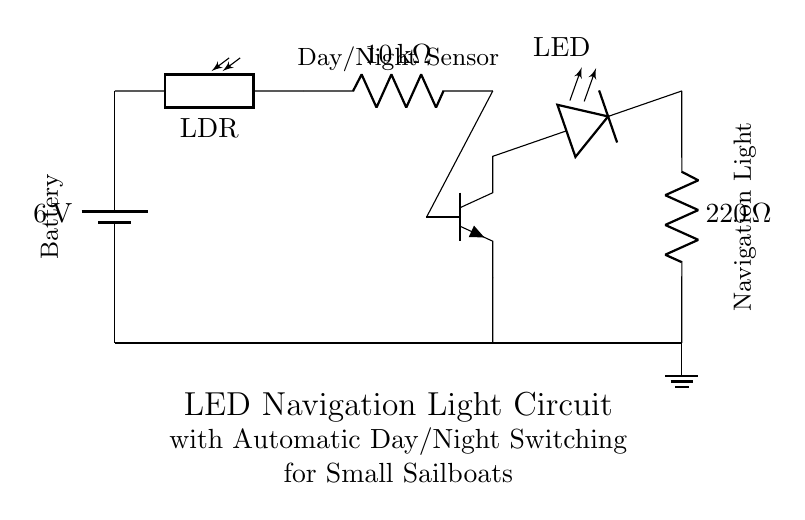What is the voltage of the battery? The circuit shows a battery labeled with a voltage of six volts, indicating the power source for the entire circuit.
Answer: six volts What is the value of the resistor connected to the LED? The circuit diagram indicates a resistor labeled with a value of two hundred twenty ohms, showing its role in limiting the current to the LED.
Answer: two hundred twenty ohms What component detects light levels? The circuit includes a photoresistor, also known as an LDR, which is used to detect light and trigger the switching of the navigation light based on day or night.
Answer: LDR Why is the transistor included in this circuit? The transistor acts as a switch that controls the LED based on the current flowing from the photoresistor, allowing the navigation light to turn on at night when light levels drop.
Answer: To control the LED What happens to the LED during daytime? The LED will remain off during the daytime when the light intensity is high enough to keep the photoresistor conducting, effectively preventing current flow through the LED.
Answer: LED is off What is the main purpose of this circuit? The primary function of this circuit is to provide automatic day/night switching for navigation lights on small sailboats, ensuring the lights are active during low light conditions.
Answer: Automatic switching 